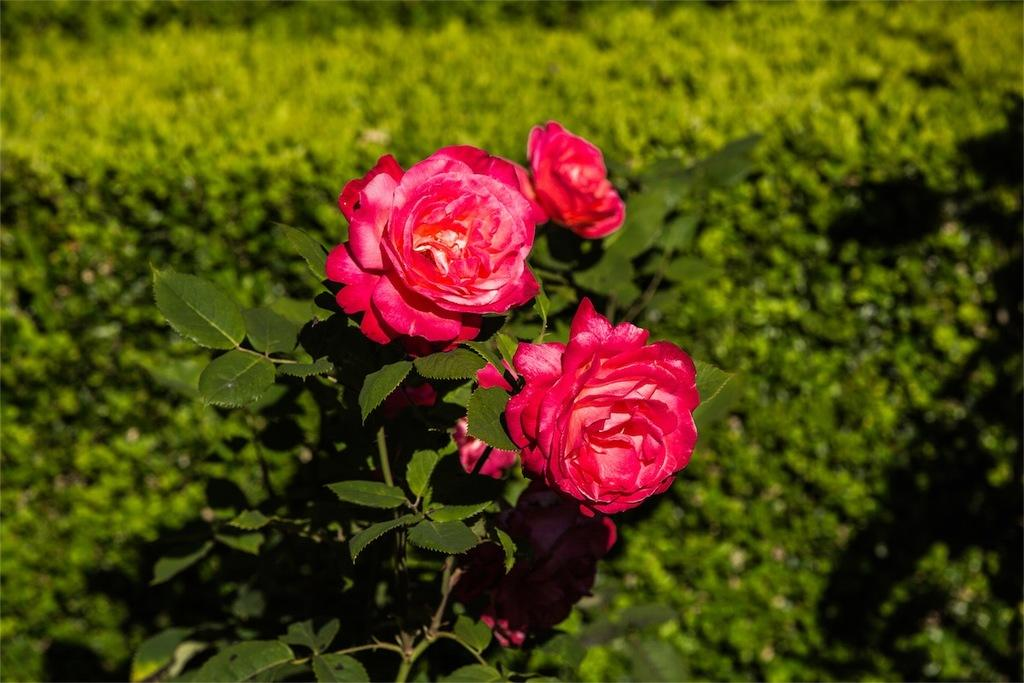What is the main subject of the image? There is a group of flowers in the image. What else can be seen in the image besides the flowers? There are leaves visible in the image. What can be seen in the background of the image? There are plants visible in the background of the image. What type of slave is depicted in the image? There is no depiction of a slave in the image; it features a group of flowers, leaves, and plants in the background. 